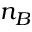<formula> <loc_0><loc_0><loc_500><loc_500>n _ { B }</formula> 